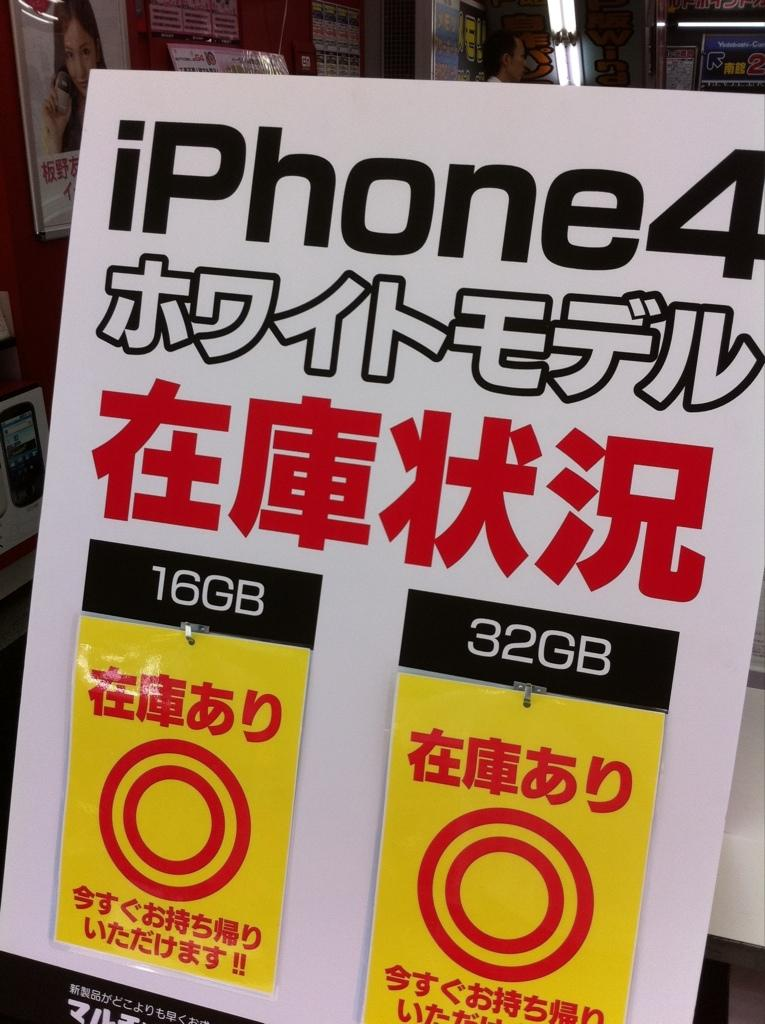<image>
Share a concise interpretation of the image provided. A poster for an iPhone 4 in Chinese, offered in two versions 16 & 32 GB. 